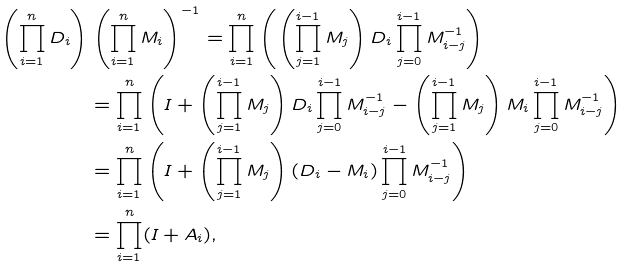Convert formula to latex. <formula><loc_0><loc_0><loc_500><loc_500>\left ( \prod _ { i = 1 } ^ { n } D _ { i } \right ) & \left ( \prod _ { i = 1 } ^ { n } M _ { i } \right ) ^ { - 1 } = \prod _ { i = 1 } ^ { n } \left ( \left ( \prod _ { j = 1 } ^ { i - 1 } M _ { j } \right ) D _ { i } \prod _ { j = 0 } ^ { i - 1 } M _ { i - j } ^ { - 1 } \right ) \\ & = \prod _ { i = 1 } ^ { n } \left ( I + \left ( \prod _ { j = 1 } ^ { i - 1 } M _ { j } \right ) D _ { i } \prod _ { j = 0 } ^ { i - 1 } M _ { i - j } ^ { - 1 } - \left ( \prod _ { j = 1 } ^ { i - 1 } M _ { j } \right ) M _ { i } \prod _ { j = 0 } ^ { i - 1 } M _ { i - j } ^ { - 1 } \right ) \\ & = \prod _ { i = 1 } ^ { n } \left ( I + \left ( \prod _ { j = 1 } ^ { i - 1 } M _ { j } \right ) ( D _ { i } - M _ { i } ) \prod _ { j = 0 } ^ { i - 1 } M _ { i - j } ^ { - 1 } \right ) \\ & = \prod _ { i = 1 } ^ { n } ( I + A _ { i } ) ,</formula> 